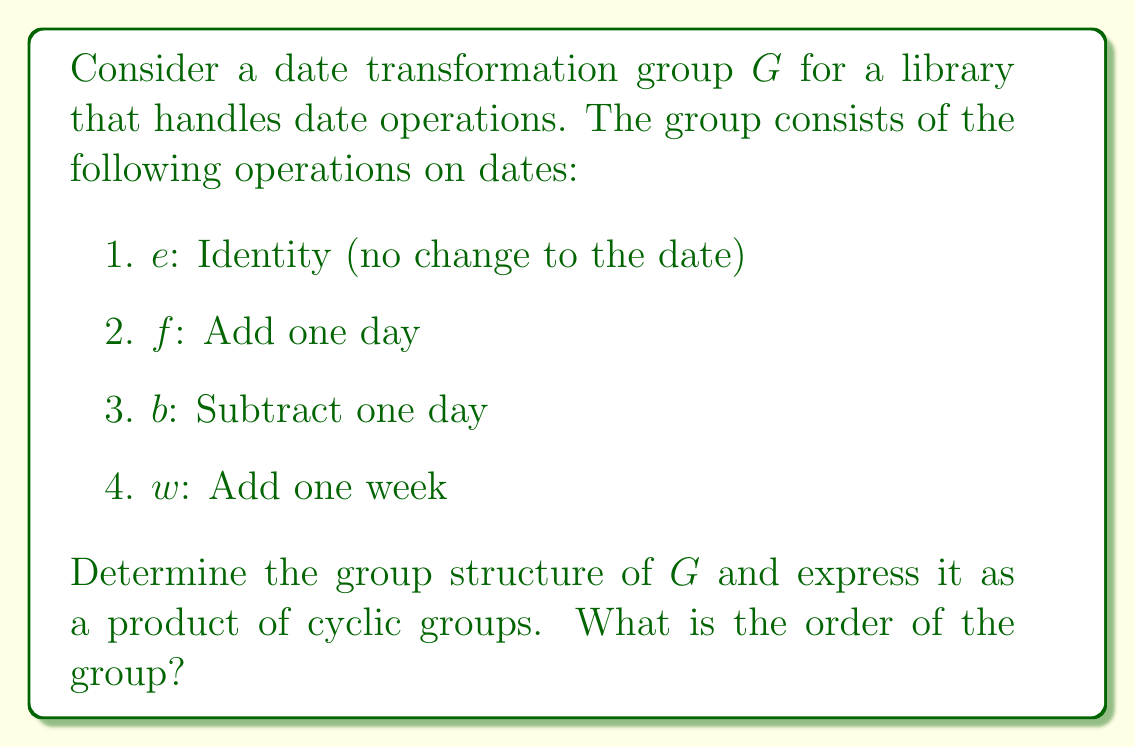Teach me how to tackle this problem. To determine the group structure, let's analyze the properties of the operations:

1. First, note that $f$ and $b$ are inverse operations: $f \circ b = b \circ f = e$

2. Adding a week ($w$) is equivalent to adding a day seven times: $w = f^7$

3. The operation $f$ generates all elements of the group:
   $e = f^0$
   $f = f^1$
   $b = f^{-1}$
   $w = f^7$

4. There is no finite order for $f$, as repeatedly adding days will never return to the starting date (ignoring practical limitations of date representations in computer systems).

5. The group operation is composition of functions, which is associative.

Given these observations, we can conclude that:

- The group $G$ is isomorphic to the group of integers under addition, $(\mathbb{Z}, +)$
- It is an infinite cyclic group generated by $f$
- It can be written as $G \cong \langle f \rangle \cong \mathbb{Z}$

The group structure is therefore a single infinite cyclic group.
Answer: The group $G$ is isomorphic to $\mathbb{Z}$, the infinite cyclic group. Its structure can be expressed as $G \cong C_\infty$, where $C_\infty$ denotes the infinite cyclic group. The order of the group is infinite. 